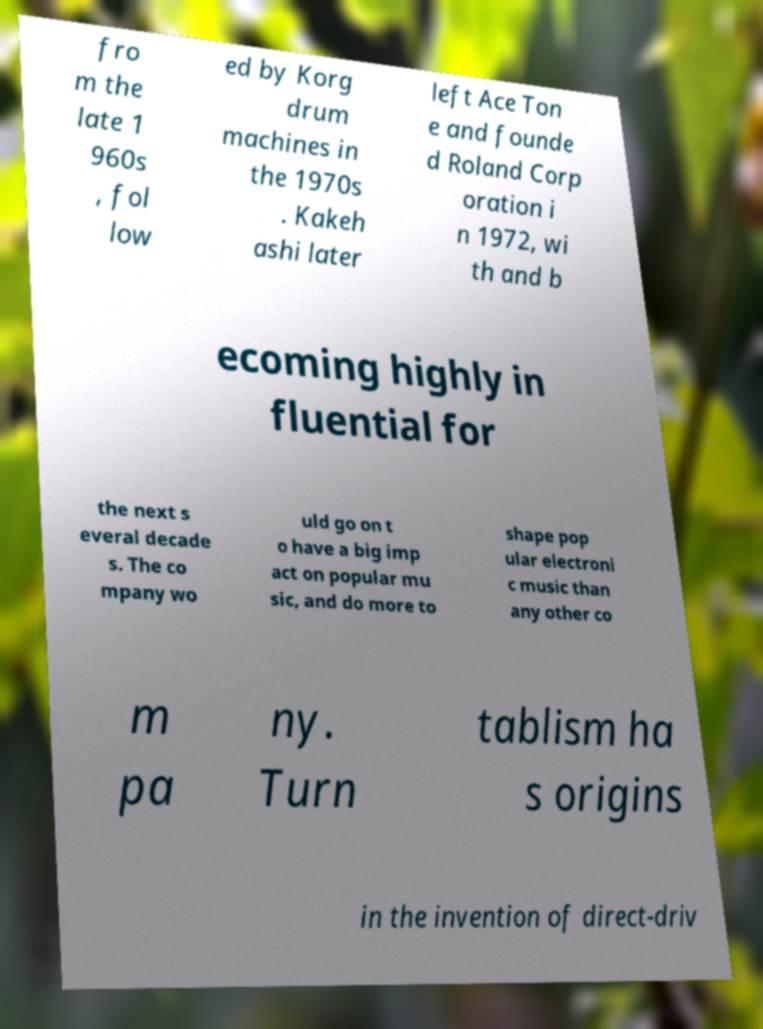For documentation purposes, I need the text within this image transcribed. Could you provide that? fro m the late 1 960s , fol low ed by Korg drum machines in the 1970s . Kakeh ashi later left Ace Ton e and founde d Roland Corp oration i n 1972, wi th and b ecoming highly in fluential for the next s everal decade s. The co mpany wo uld go on t o have a big imp act on popular mu sic, and do more to shape pop ular electroni c music than any other co m pa ny. Turn tablism ha s origins in the invention of direct-driv 